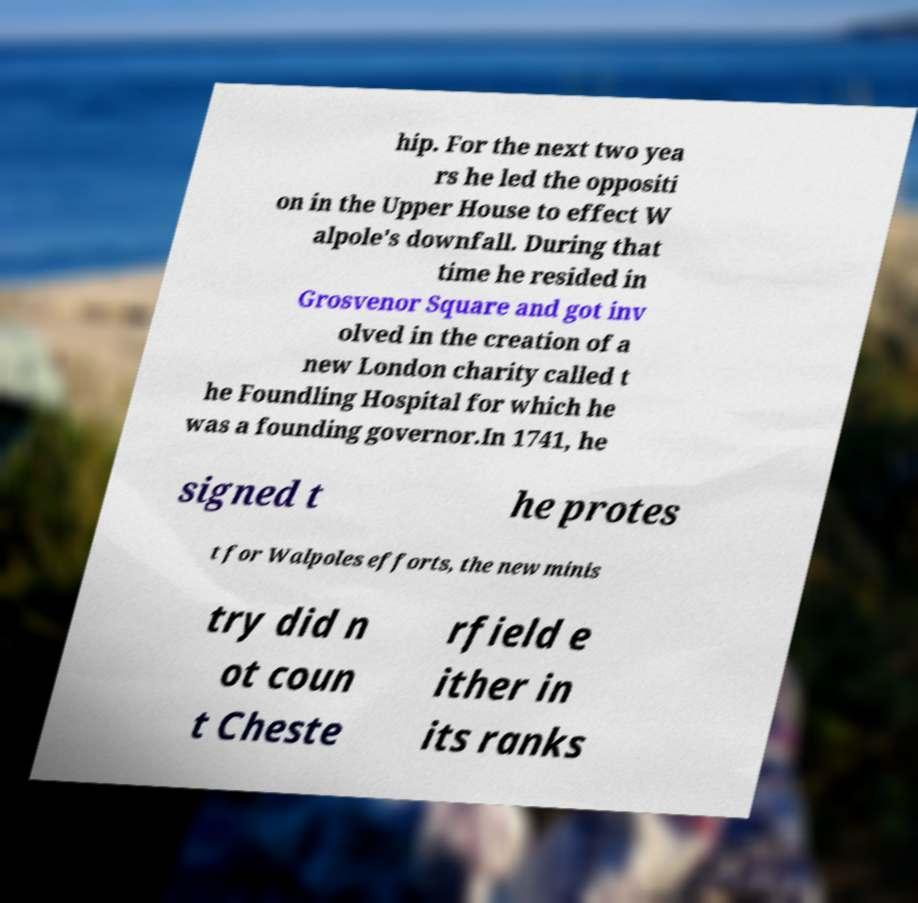There's text embedded in this image that I need extracted. Can you transcribe it verbatim? hip. For the next two yea rs he led the oppositi on in the Upper House to effect W alpole's downfall. During that time he resided in Grosvenor Square and got inv olved in the creation of a new London charity called t he Foundling Hospital for which he was a founding governor.In 1741, he signed t he protes t for Walpoles efforts, the new minis try did n ot coun t Cheste rfield e ither in its ranks 